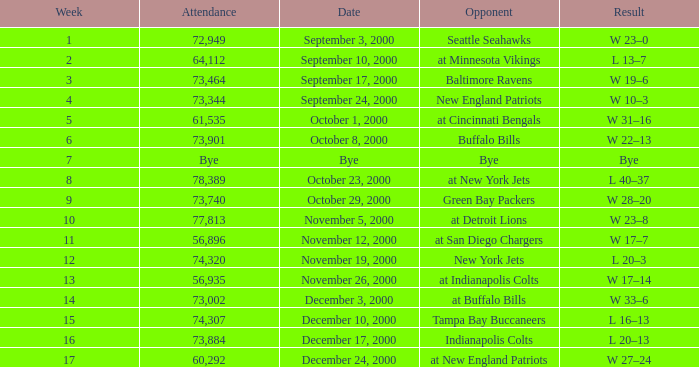Could you help me parse every detail presented in this table? {'header': ['Week', 'Attendance', 'Date', 'Opponent', 'Result'], 'rows': [['1', '72,949', 'September 3, 2000', 'Seattle Seahawks', 'W 23–0'], ['2', '64,112', 'September 10, 2000', 'at Minnesota Vikings', 'L 13–7'], ['3', '73,464', 'September 17, 2000', 'Baltimore Ravens', 'W 19–6'], ['4', '73,344', 'September 24, 2000', 'New England Patriots', 'W 10–3'], ['5', '61,535', 'October 1, 2000', 'at Cincinnati Bengals', 'W 31–16'], ['6', '73,901', 'October 8, 2000', 'Buffalo Bills', 'W 22–13'], ['7', 'Bye', 'Bye', 'Bye', 'Bye'], ['8', '78,389', 'October 23, 2000', 'at New York Jets', 'L 40–37'], ['9', '73,740', 'October 29, 2000', 'Green Bay Packers', 'W 28–20'], ['10', '77,813', 'November 5, 2000', 'at Detroit Lions', 'W 23–8'], ['11', '56,896', 'November 12, 2000', 'at San Diego Chargers', 'W 17–7'], ['12', '74,320', 'November 19, 2000', 'New York Jets', 'L 20–3'], ['13', '56,935', 'November 26, 2000', 'at Indianapolis Colts', 'W 17–14'], ['14', '73,002', 'December 3, 2000', 'at Buffalo Bills', 'W 33–6'], ['15', '74,307', 'December 10, 2000', 'Tampa Bay Buccaneers', 'L 16–13'], ['16', '73,884', 'December 17, 2000', 'Indianapolis Colts', 'L 20–13'], ['17', '60,292', 'December 24, 2000', 'at New England Patriots', 'W 27–24']]} What is the Result of the game against the Indianapolis Colts? L 20–13. 